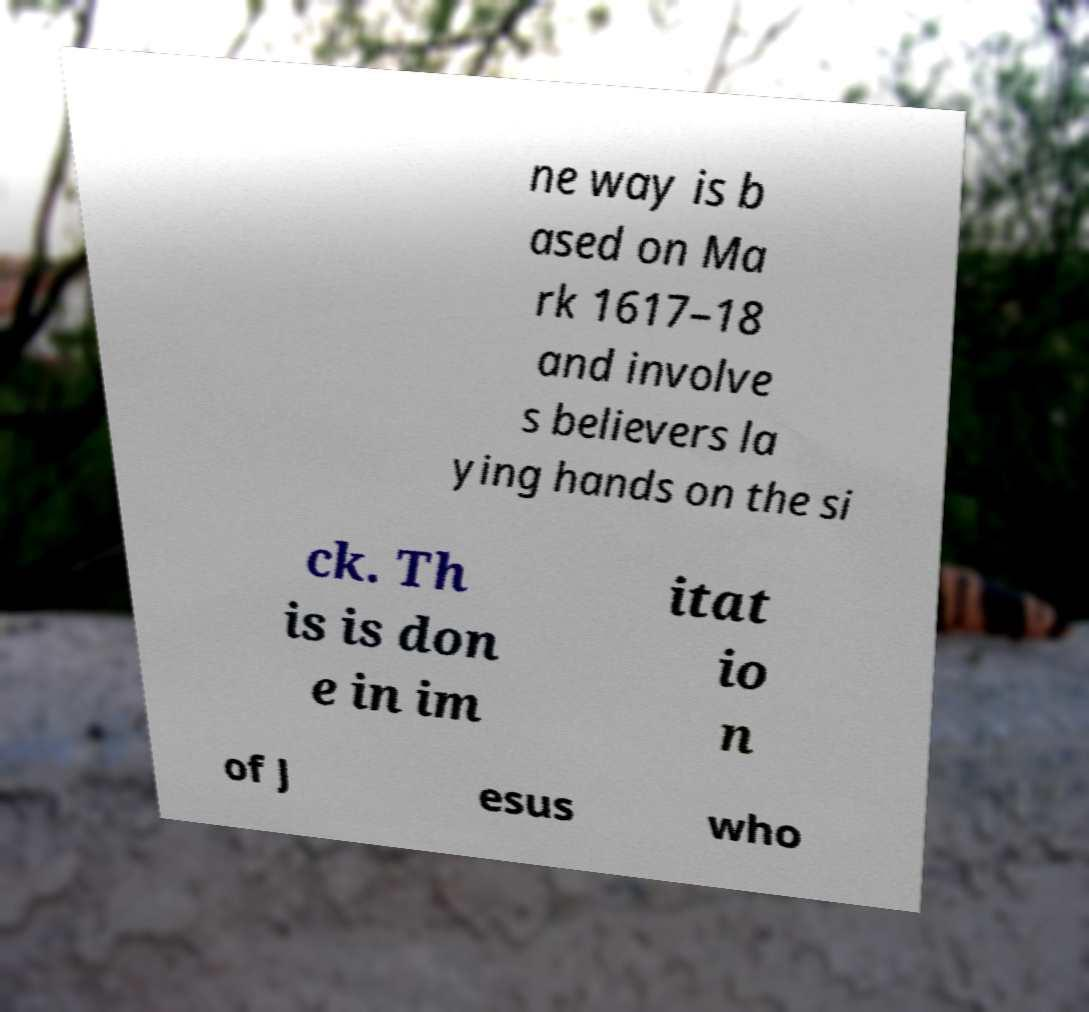There's text embedded in this image that I need extracted. Can you transcribe it verbatim? ne way is b ased on Ma rk 1617–18 and involve s believers la ying hands on the si ck. Th is is don e in im itat io n of J esus who 